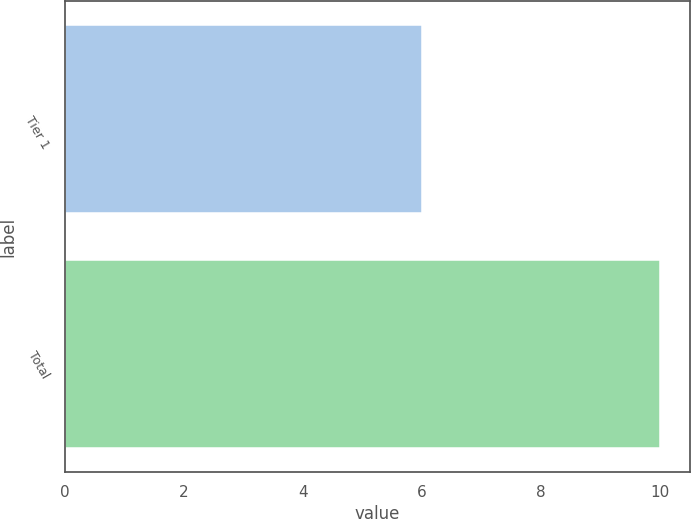Convert chart. <chart><loc_0><loc_0><loc_500><loc_500><bar_chart><fcel>Tier 1<fcel>Total<nl><fcel>6<fcel>10<nl></chart> 